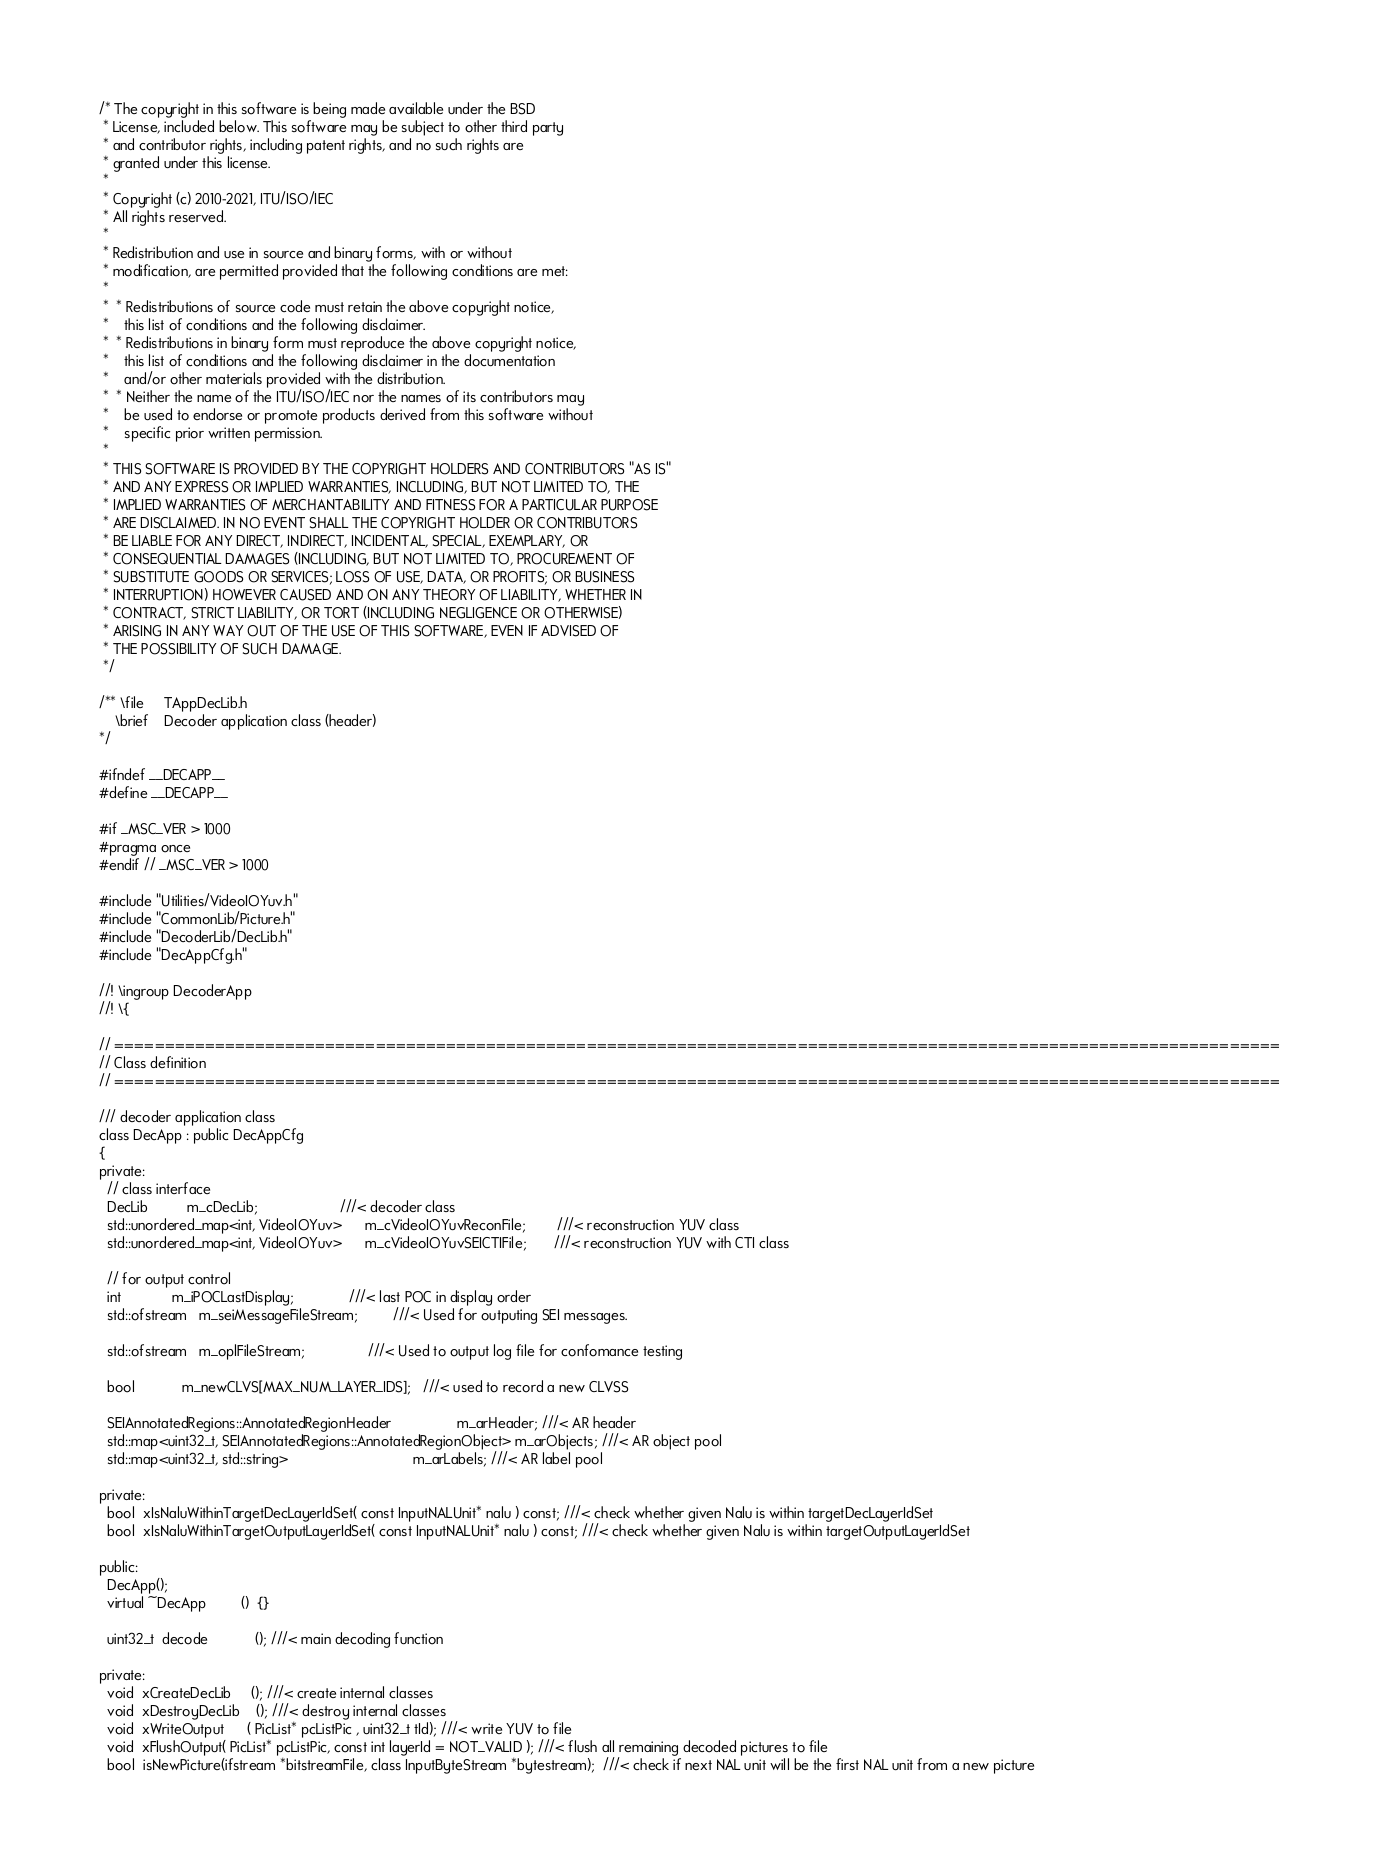Convert code to text. <code><loc_0><loc_0><loc_500><loc_500><_C_>/* The copyright in this software is being made available under the BSD
 * License, included below. This software may be subject to other third party
 * and contributor rights, including patent rights, and no such rights are
 * granted under this license.
 *
 * Copyright (c) 2010-2021, ITU/ISO/IEC
 * All rights reserved.
 *
 * Redistribution and use in source and binary forms, with or without
 * modification, are permitted provided that the following conditions are met:
 *
 *  * Redistributions of source code must retain the above copyright notice,
 *    this list of conditions and the following disclaimer.
 *  * Redistributions in binary form must reproduce the above copyright notice,
 *    this list of conditions and the following disclaimer in the documentation
 *    and/or other materials provided with the distribution.
 *  * Neither the name of the ITU/ISO/IEC nor the names of its contributors may
 *    be used to endorse or promote products derived from this software without
 *    specific prior written permission.
 *
 * THIS SOFTWARE IS PROVIDED BY THE COPYRIGHT HOLDERS AND CONTRIBUTORS "AS IS"
 * AND ANY EXPRESS OR IMPLIED WARRANTIES, INCLUDING, BUT NOT LIMITED TO, THE
 * IMPLIED WARRANTIES OF MERCHANTABILITY AND FITNESS FOR A PARTICULAR PURPOSE
 * ARE DISCLAIMED. IN NO EVENT SHALL THE COPYRIGHT HOLDER OR CONTRIBUTORS
 * BE LIABLE FOR ANY DIRECT, INDIRECT, INCIDENTAL, SPECIAL, EXEMPLARY, OR
 * CONSEQUENTIAL DAMAGES (INCLUDING, BUT NOT LIMITED TO, PROCUREMENT OF
 * SUBSTITUTE GOODS OR SERVICES; LOSS OF USE, DATA, OR PROFITS; OR BUSINESS
 * INTERRUPTION) HOWEVER CAUSED AND ON ANY THEORY OF LIABILITY, WHETHER IN
 * CONTRACT, STRICT LIABILITY, OR TORT (INCLUDING NEGLIGENCE OR OTHERWISE)
 * ARISING IN ANY WAY OUT OF THE USE OF THIS SOFTWARE, EVEN IF ADVISED OF
 * THE POSSIBILITY OF SUCH DAMAGE.
 */

/** \file     TAppDecLib.h
    \brief    Decoder application class (header)
*/

#ifndef __DECAPP__
#define __DECAPP__

#if _MSC_VER > 1000
#pragma once
#endif // _MSC_VER > 1000

#include "Utilities/VideoIOYuv.h"
#include "CommonLib/Picture.h"
#include "DecoderLib/DecLib.h"
#include "DecAppCfg.h"

//! \ingroup DecoderApp
//! \{

// ====================================================================================================================
// Class definition
// ====================================================================================================================

/// decoder application class
class DecApp : public DecAppCfg
{
private:
  // class interface
  DecLib          m_cDecLib;                     ///< decoder class
  std::unordered_map<int, VideoIOYuv>      m_cVideoIOYuvReconFile;        ///< reconstruction YUV class
  std::unordered_map<int, VideoIOYuv>      m_cVideoIOYuvSEICTIFile;       ///< reconstruction YUV with CTI class

  // for output control
  int             m_iPOCLastDisplay;              ///< last POC in display order
  std::ofstream   m_seiMessageFileStream;         ///< Used for outputing SEI messages.

  std::ofstream   m_oplFileStream;                ///< Used to output log file for confomance testing

  bool            m_newCLVS[MAX_NUM_LAYER_IDS];   ///< used to record a new CLVSS

  SEIAnnotatedRegions::AnnotatedRegionHeader                 m_arHeader; ///< AR header
  std::map<uint32_t, SEIAnnotatedRegions::AnnotatedRegionObject> m_arObjects; ///< AR object pool
  std::map<uint32_t, std::string>                                m_arLabels; ///< AR label pool

private:
  bool  xIsNaluWithinTargetDecLayerIdSet( const InputNALUnit* nalu ) const; ///< check whether given Nalu is within targetDecLayerIdSet
  bool  xIsNaluWithinTargetOutputLayerIdSet( const InputNALUnit* nalu ) const; ///< check whether given Nalu is within targetOutputLayerIdSet

public:
  DecApp();
  virtual ~DecApp         ()  {}

  uint32_t  decode            (); ///< main decoding function

private:
  void  xCreateDecLib     (); ///< create internal classes
  void  xDestroyDecLib    (); ///< destroy internal classes
  void  xWriteOutput      ( PicList* pcListPic , uint32_t tId); ///< write YUV to file
  void  xFlushOutput( PicList* pcListPic, const int layerId = NOT_VALID ); ///< flush all remaining decoded pictures to file
  bool  isNewPicture(ifstream *bitstreamFile, class InputByteStream *bytestream);  ///< check if next NAL unit will be the first NAL unit from a new picture</code> 